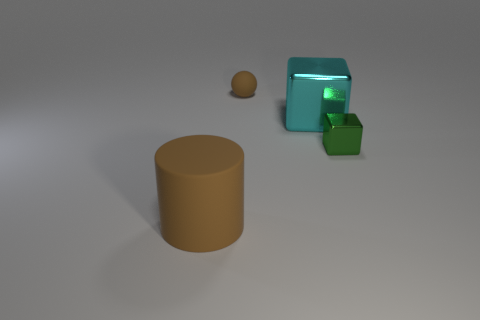Add 1 small matte things. How many objects exist? 5 Subtract all cylinders. How many objects are left? 3 Add 2 brown rubber spheres. How many brown rubber spheres are left? 3 Add 1 matte cylinders. How many matte cylinders exist? 2 Subtract 1 cyan cubes. How many objects are left? 3 Subtract all large things. Subtract all big cylinders. How many objects are left? 1 